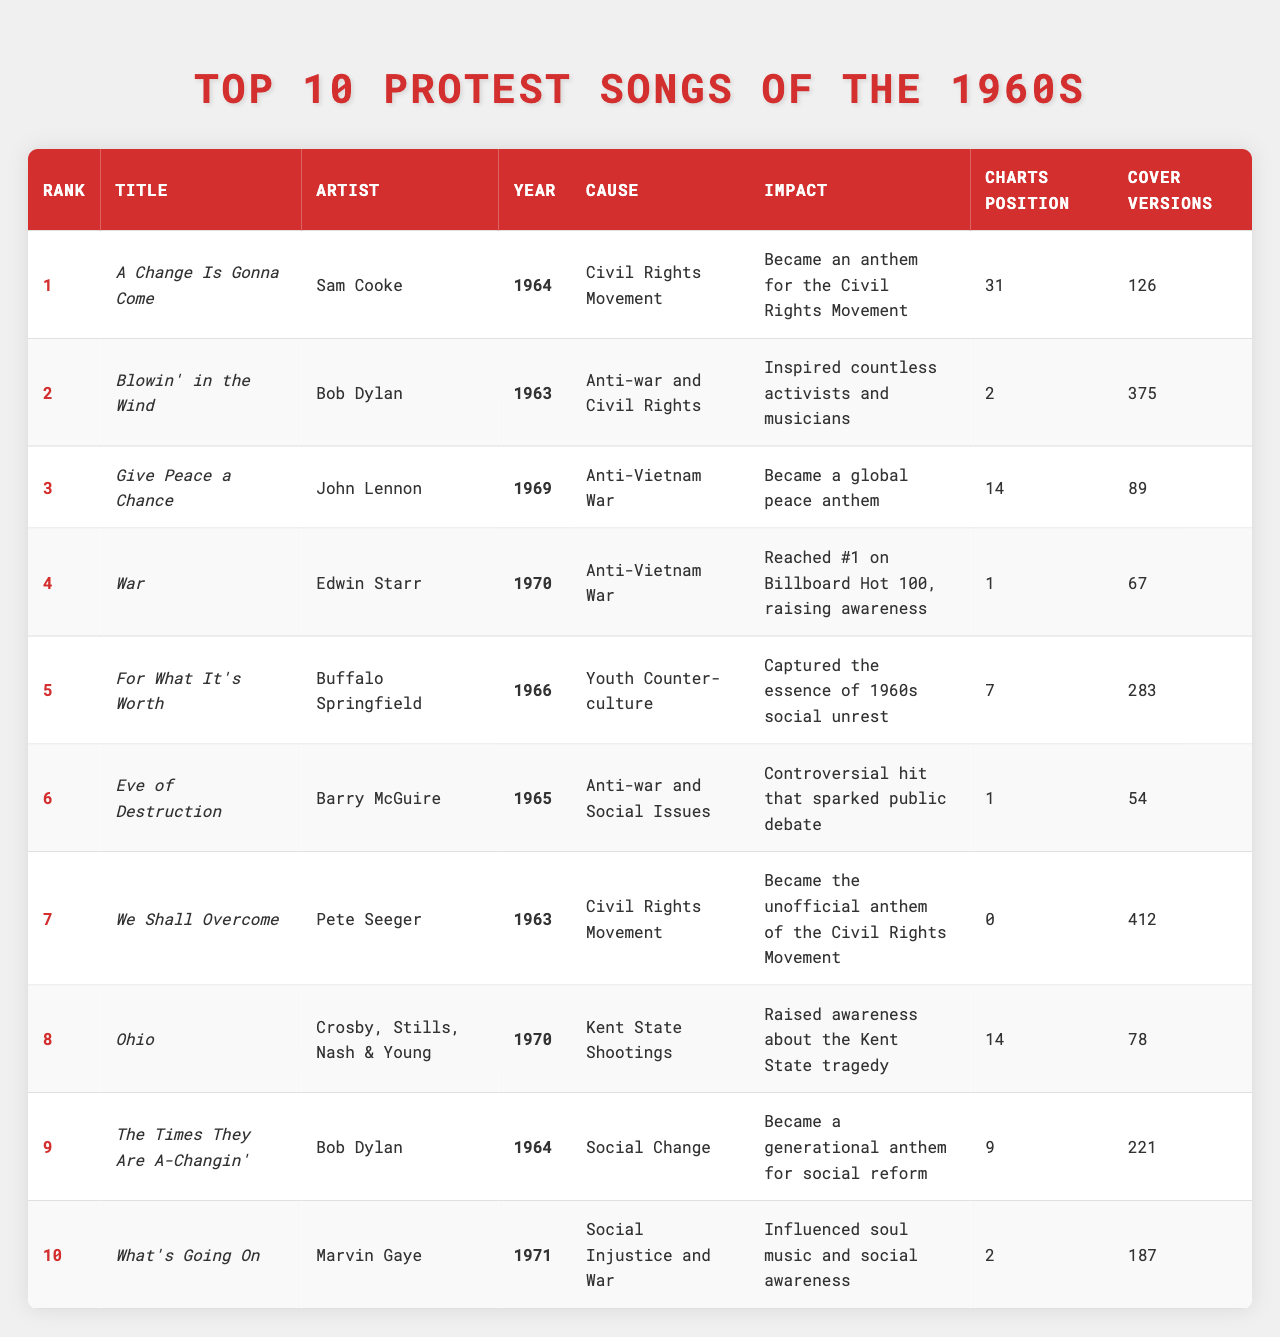What's the title of the song ranked 1st? The title can be found in the first row of the table under "Title" for the song that has a rank of 1. Referring to the table, the title is "A Change Is Gonna Come".
Answer: A Change Is Gonna Come Who is the artist of the song "Blowin' in the Wind"? To find this, look at the row of the song "Blowin' in the Wind" and check the corresponding "Artist" column. The artist is Bob Dylan.
Answer: Bob Dylan What year was "Give Peace a Chance" released? Simply look at the row for "Give Peace a Chance" and check the "Year" column to find it. This song was released in 1969.
Answer: 1969 How many cover versions does "War" have? The number of cover versions for the song "War" can be found in its corresponding row under the "Cover Versions" column, which states that there are 67 cover versions.
Answer: 67 Which song has the highest charts position? The highest charts position can be determined by inspecting the "Charts Position" column for the song that has a value of 1, which is "War".
Answer: War What is the impact of the song "Eve of Destruction"? To find this information, look for "Eve of Destruction" and read its impact listed in the "Impact" column. The impact is known to be a controversial hit that sparked public debate.
Answer: Controversial hit that sparked public debate Which protest song inspired countless activists and musicians? By searching through the "Impact" column, you can find that "Blowin' in the Wind" is the song referred to, which specifically states it inspired countless activists and musicians.
Answer: Blowin' in the Wind How many protest songs were part of the Civil Rights Movement? By counting the entries in the "Cause" column that state "Civil Rights Movement", we find there are 3 songs: "A Change Is Gonna Come", "We Shall Overcome", and "Blowin' in the Wind".
Answer: 3 What are the causes for the songs ranked from 1 to 5? Look at the "Cause" column and list the causes for the top 5 ranked songs: 1. Civil Rights Movement, 2. Anti-war and Civil Rights, 3. Anti-Vietnam War, 4. Anti-Vietnam War, 5. Youth Counter-culture.
Answer: Civil Rights Movement, Anti-war and Civil Rights, Anti-Vietnam War, Anti-Vietnam War, Youth Counter-culture Which song had the most cover versions? By examining the "Cover Versions" column, you will see that "We Shall Overcome" has 412 cover versions, making it the song with the most cover versions.
Answer: We Shall Overcome What is the difference in charts positions between "Give Peace a Chance" and "The Times They Are A-Changin'"? Check the charts positions for both songs: "Give Peace a Chance" has a position of 14 and "The Times They Are A-Changin'" has a position of 9. The difference is 14 - 9 = 5.
Answer: 5 Do any songs listed have a charts position of 0? Review the "Charts Position" column to find any entry with a value of 0, which is the case for "We Shall Overcome". Thus, the answer is yes.
Answer: Yes Which song had the largest impact on social change according to the table? Looking at the "Impact" column, we can see "The Times They Are A-Changin'" is described as a generational anthem for social reform, indicating its significant impact on social change.
Answer: The Times They Are A-Changin' How many total cover versions are there for all the songs combined? Add up the cover versions for each song: 126 + 375 + 89 + 67 + 283 + 54 + 412 + 78 + 221 + 187 = 1871 cover versions. The total is 1871.
Answer: 1871 